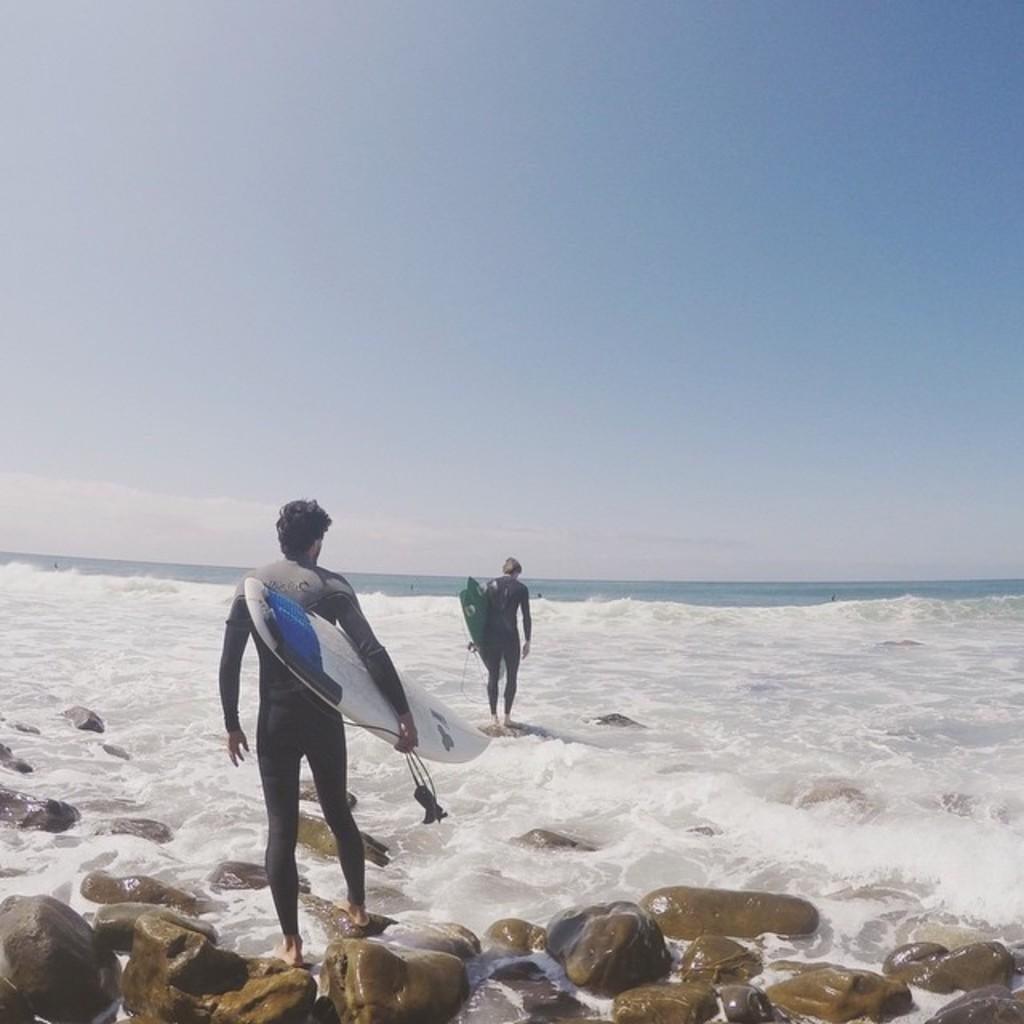In one or two sentences, can you explain what this image depicts? In the picture we can find two men are walking on the sea, they are holding a surfing board in their hands. And we can see in the background we can find sky, water. 